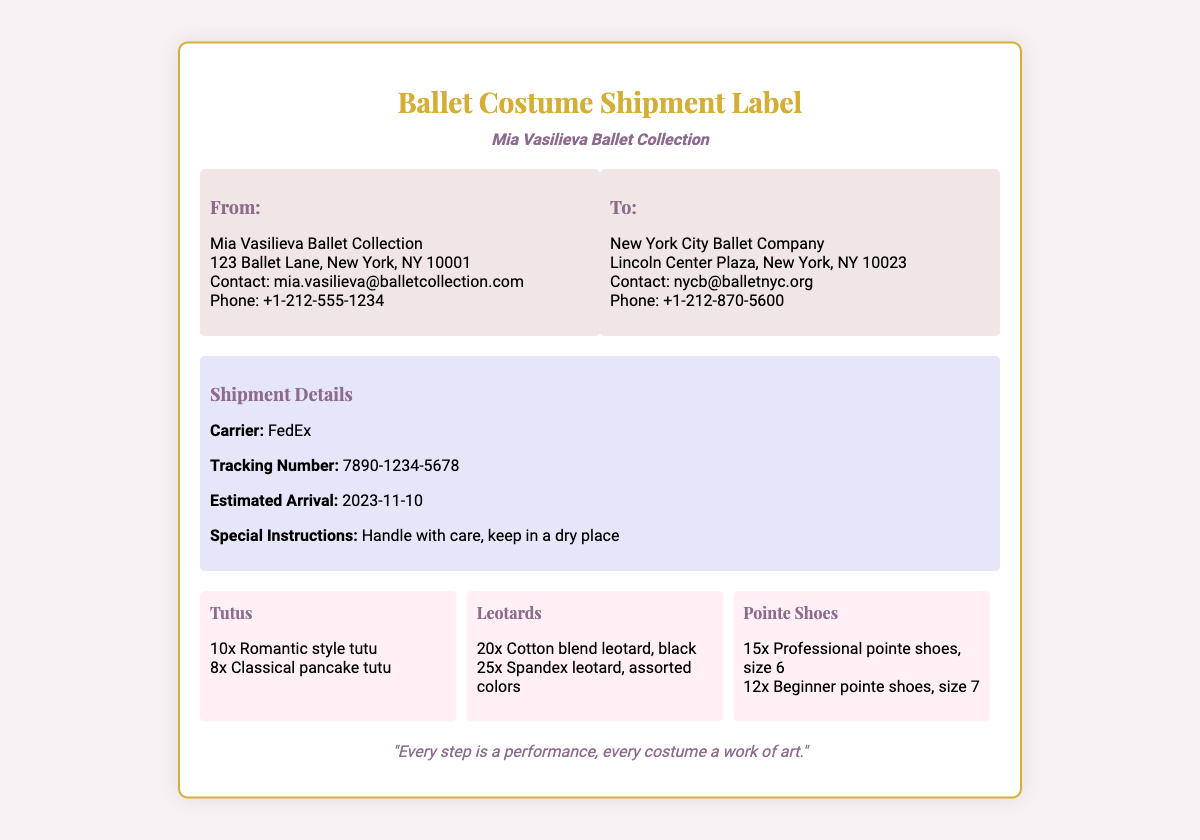What is the shipment's estimated arrival date? The estimated arrival date is explicitly stated in the shipment details section of the document.
Answer: 2023-11-10 Who is the sender of the shipment? The sender's details including name, address, and contact information can be found in the "From" section of the document.
Answer: Mia Vasilieva Ballet Collection How many romantic style tutus are included in the shipment? The count of romantic style tutus can be found in the inventory list under the item "Tutus."
Answer: 10 What carrier is used for this shipment? The carrier's name is mentioned in the shipment details section.
Answer: FedEx What is the tracking number for the shipment? The tracking number is explicitly listed under the shipment details section in the document.
Answer: 7890-1234-5678 What type of pointe shoes are included for beginners? The type of pointe shoes for beginners is mentioned in the shipment inventory.
Answer: Beginner pointe shoes What is the primary color of the first batch of leotards? The color of the first batch of leotards is specified in the inventory under the item "Leotards."
Answer: Black How many items of spandex leotards in assorted colors are included? The quantity of spandex leotards is clearly listed in the item description under "Leotards."
Answer: 25 What special instructions are provided for handling the shipment? The special instructions for handling can be found in the shipment details section.
Answer: Handle with care, keep in a dry place 